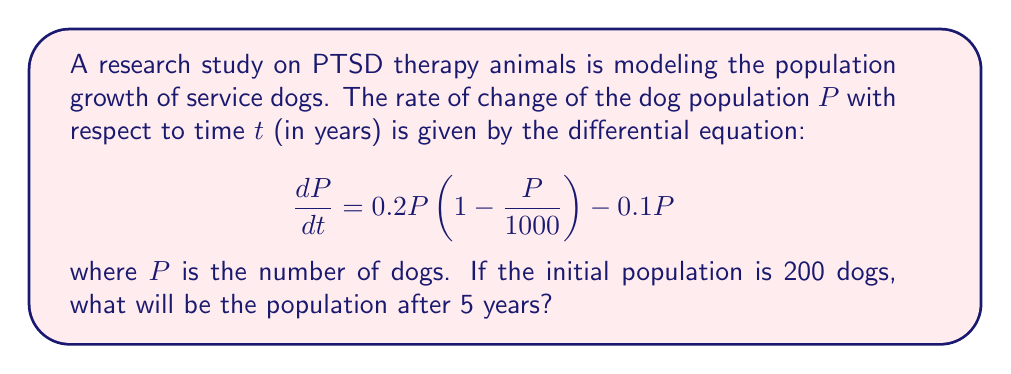Provide a solution to this math problem. To solve this problem, we need to follow these steps:

1) First, let's identify the type of differential equation. This is a logistic growth model with an additional decay term.

2) The equation can be rewritten as:
   $$\frac{dP}{dt} = 0.2P - \frac{0.2P^2}{1000} - 0.1P = 0.1P - \frac{0.2P^2}{1000}$$

3) This is a separable differential equation. We can solve it using the method of separation of variables:
   $$\int \frac{dP}{0.1P - \frac{0.2P^2}{1000}} = \int dt$$

4) The left-hand side integral is complex. The solution to this differential equation is:
   $$P(t) = \frac{500}{1 + Ce^{-0.1t}}$$
   where $C$ is a constant determined by the initial condition.

5) Given the initial condition $P(0) = 200$, we can find $C$:
   $$200 = \frac{500}{1 + C} \implies C = \frac{3}{2}$$

6) Therefore, our specific solution is:
   $$P(t) = \frac{500}{1 + \frac{3}{2}e^{-0.1t}}$$

7) To find the population after 5 years, we evaluate $P(5)$:
   $$P(5) = \frac{500}{1 + \frac{3}{2}e^{-0.5}} \approx 308.71$$

8) Rounding to the nearest whole number (as we can't have fractional dogs), we get 309 dogs.
Answer: After 5 years, the population of service dogs will be approximately 309. 